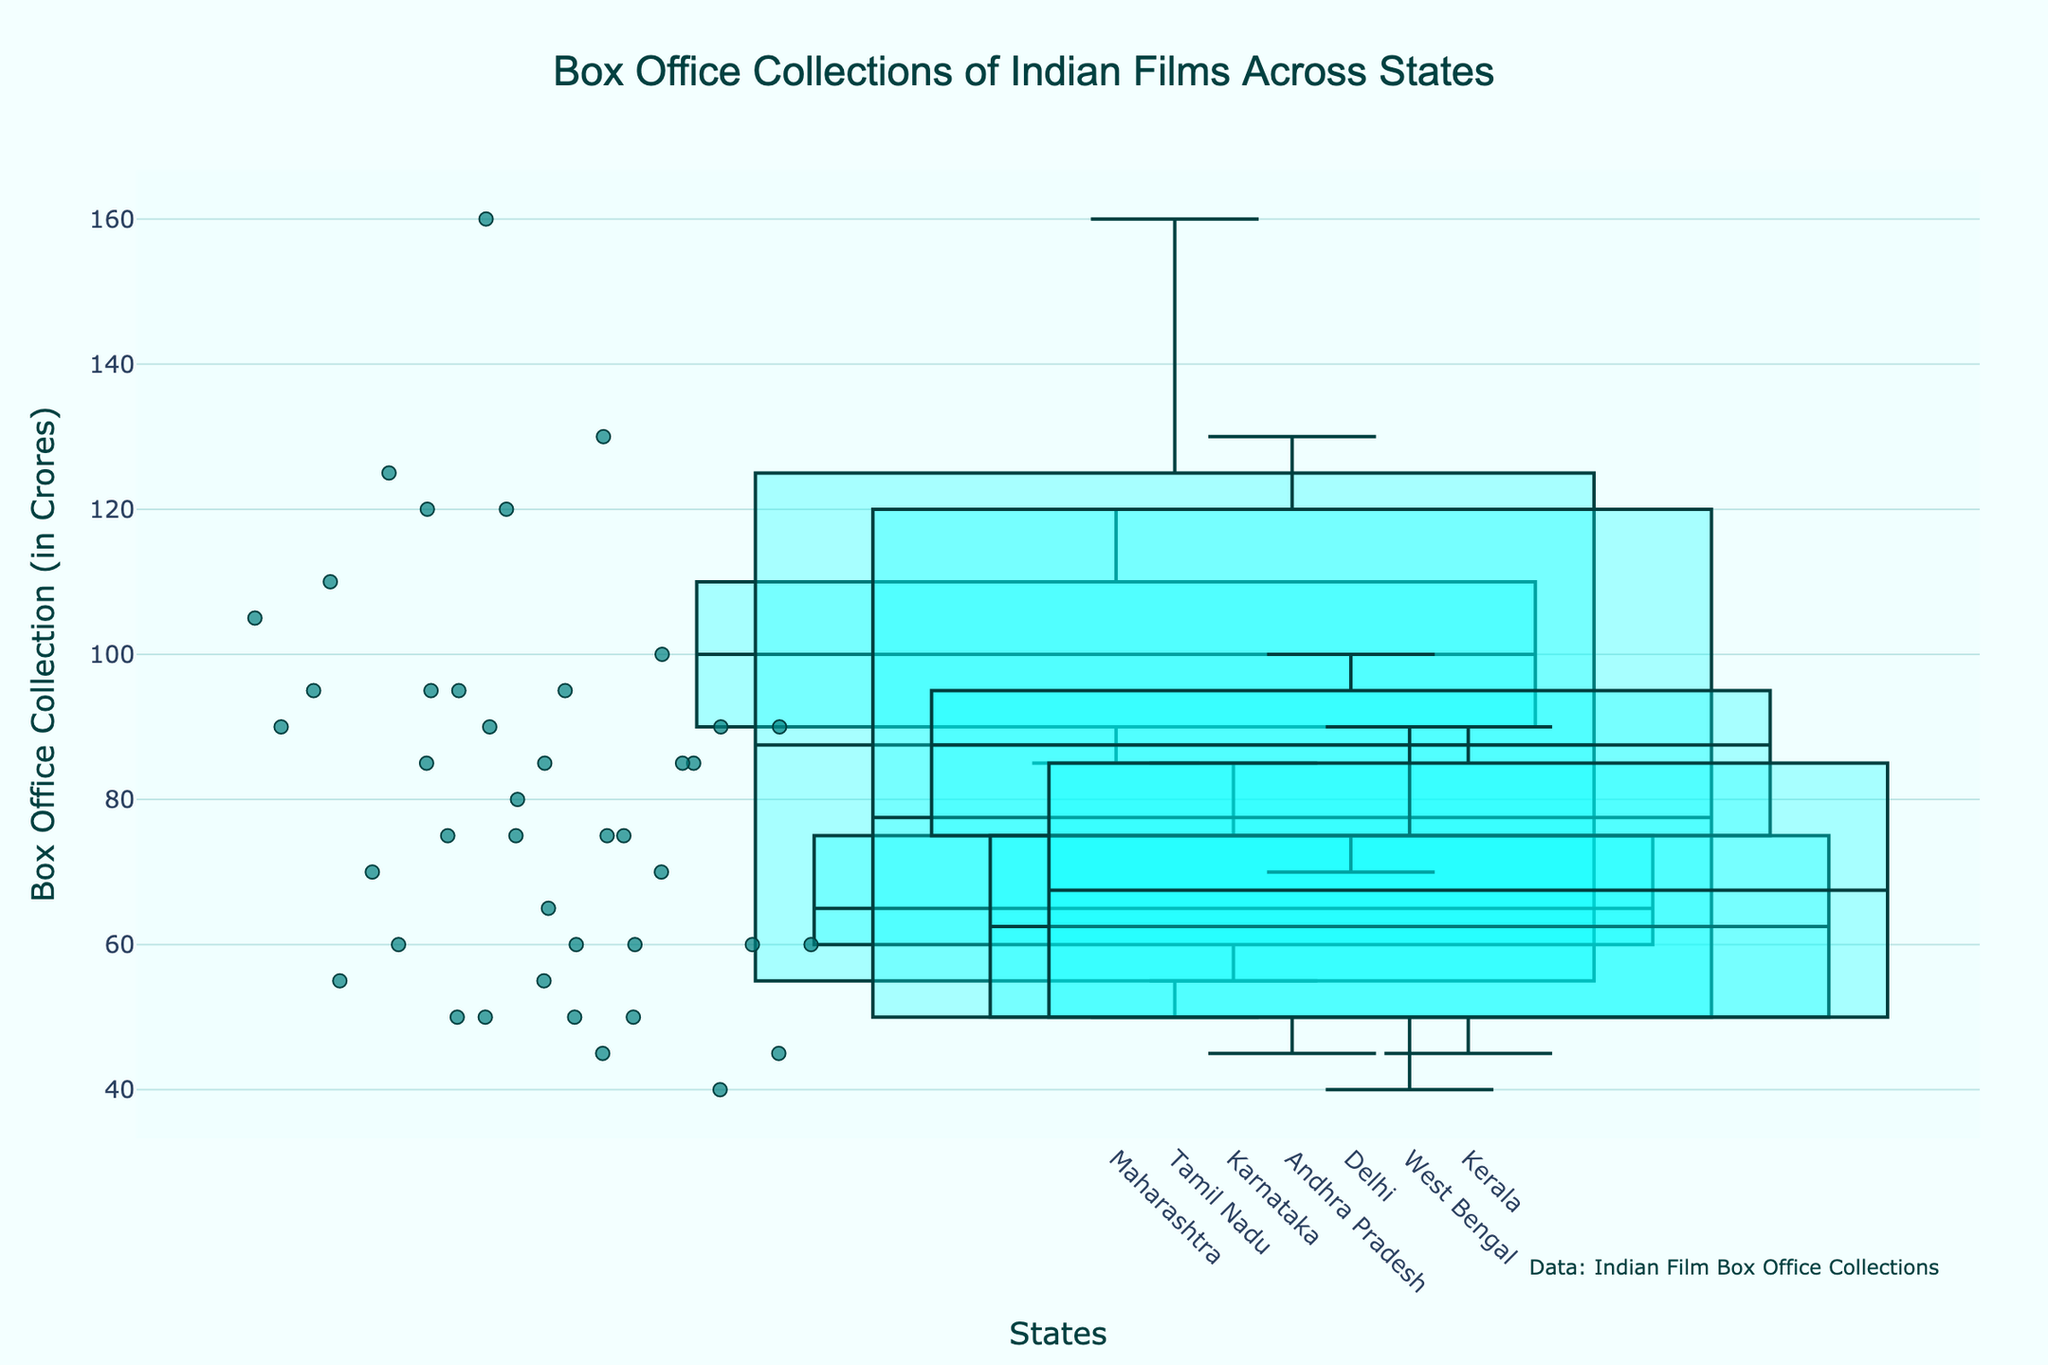Which state has the highest variation in box office collections? The widest boxes indicate the highest variation. Tamil Nadu has the widest box, indicating the highest variation in box office collections.
Answer: Tamil Nadu Which film achieved the highest box office collection in Andhra Pradesh? The top point of the box plot for Andhra Pradesh represents the highest collection, which corresponds to 'Baahubali: The Beginning' with 130 Crores.
Answer: Baahubali: The Beginning How do the median box office collections of films in Maharashtra compare to those in West Bengal? The median is represented by the line inside the box. Maharashtra's median is slightly higher than West Bengal's median.
Answer: Maharashtra's median is higher Which state has the highest median box office collection? By comparing medians (the lines inside the boxes), Andhra Pradesh has the highest median, indicating higher central tendency in box office collections.
Answer: Andhra Pradesh What's the range of box office collections in Karnataka? The range is the difference between the maximum and minimum values. Karnataka's range is 85 (Baahubali: The Beginning) - 55 (3 Idiots) = 30 Crores.
Answer: 30 Crores Which state shows the smallest width of the box plot? The narrowest box indicates the smallest width, which is Karnataka.
Answer: Karnataka Which state has the most number of data points represented in the box plot? The width of the boxes indicates the number of data points. Maharashtra, with the widest box, has the most data points.
Answer: Maharashtra Is the distribution of box office collections in Kerala more skewed towards higher or lower values? The box shows more spread towards the higher end, indicating a skew towards higher values.
Answer: Higher values Compare the interquartile ranges (IQR) of Maharashtra and Delhi. Which one is larger? The IQR is the box's height. Maharashtra's box is taller, indicating a larger IQR compared to Delhi.
Answer: Maharashtra Which film has the lowest box office collection in West Bengal? The lowest point on the box plot for West Bengal indicates the lowest collection, corresponding to 'Autograph' with 40 Crores.
Answer: Autograph 